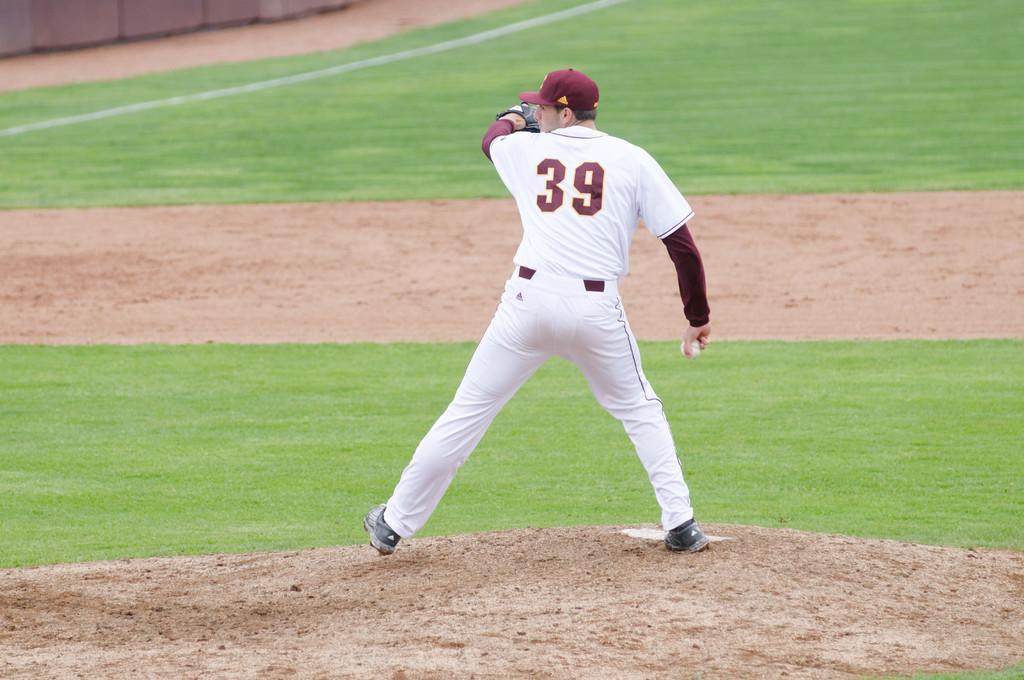Could you give a brief overview of what you see in this image? In this image in the center there is a man standing. In the background there is grass on the ground. 